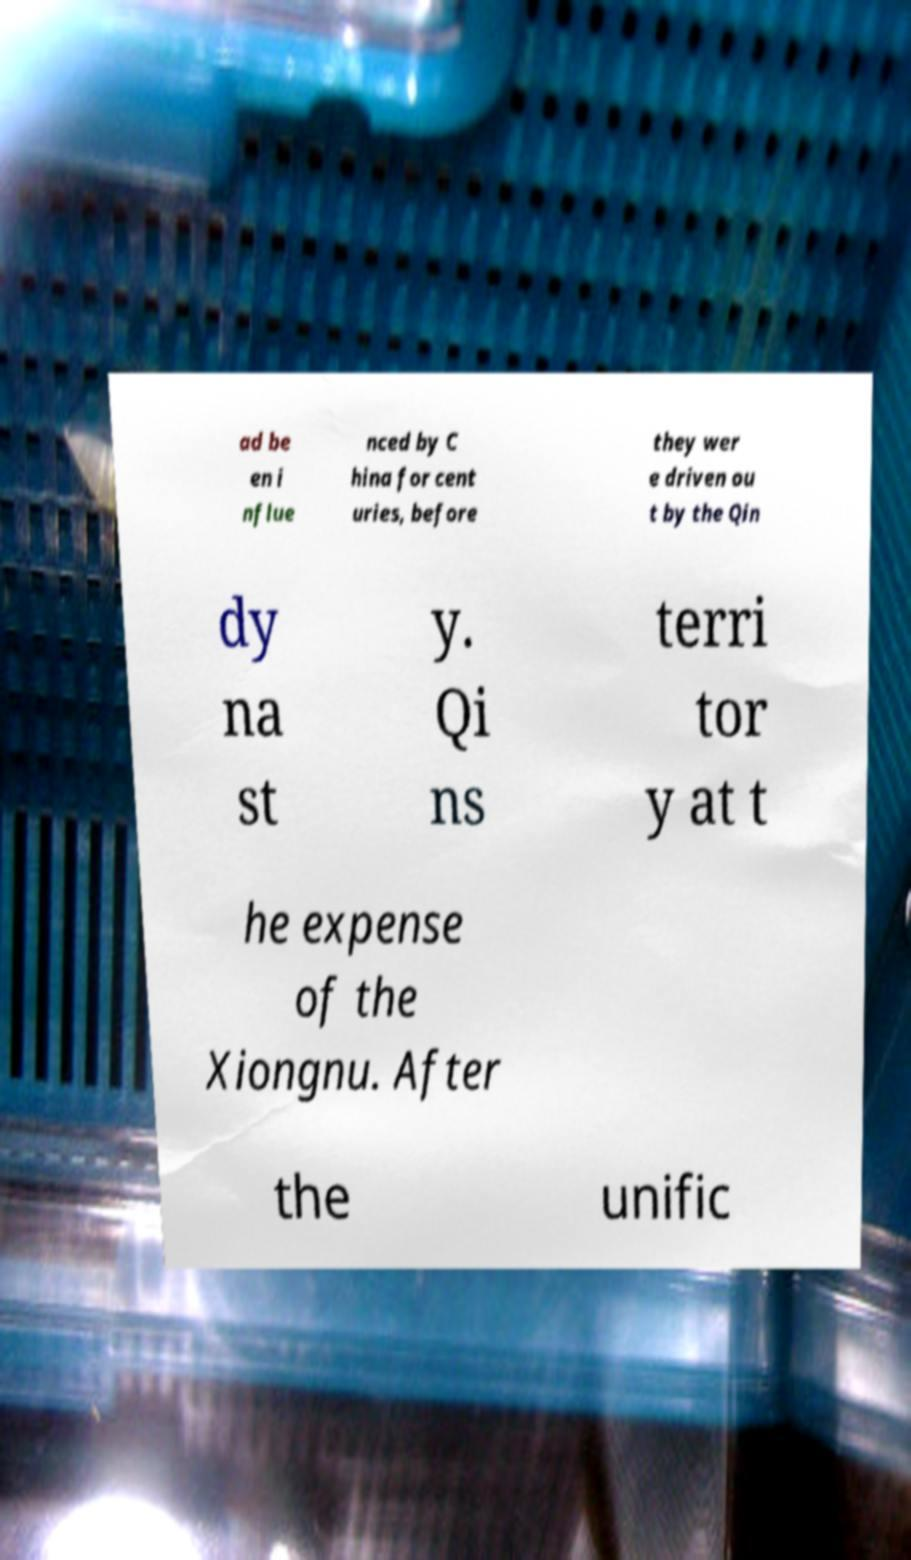For documentation purposes, I need the text within this image transcribed. Could you provide that? ad be en i nflue nced by C hina for cent uries, before they wer e driven ou t by the Qin dy na st y. Qi ns terri tor y at t he expense of the Xiongnu. After the unific 